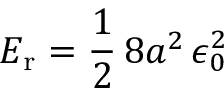Convert formula to latex. <formula><loc_0><loc_0><loc_500><loc_500>E _ { r } = { \frac { 1 } { 2 } } \, 8 a ^ { 2 } \, \epsilon _ { 0 } ^ { 2 }</formula> 